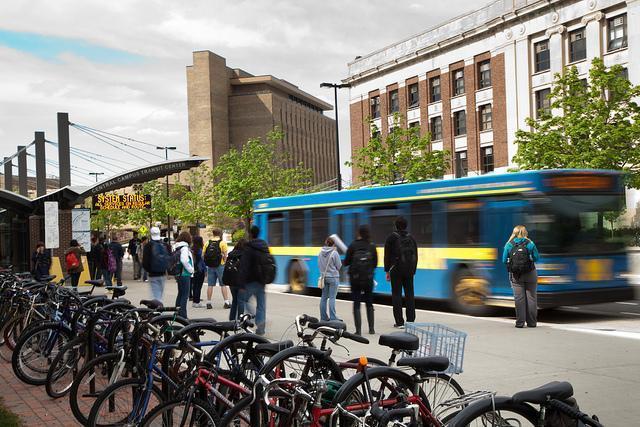How many bicycles are visible?
Give a very brief answer. 8. How many buses can you see?
Give a very brief answer. 1. How many people are in the picture?
Give a very brief answer. 3. 